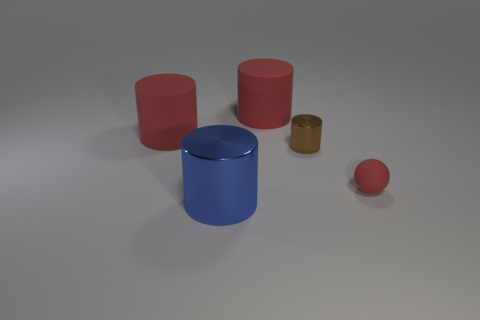Is the number of brown cylinders left of the large metallic thing greater than the number of objects?
Make the answer very short. No. The brown object that is made of the same material as the large blue object is what shape?
Ensure brevity in your answer.  Cylinder. There is a metallic cylinder behind the tiny red rubber sphere that is behind the large blue shiny cylinder; what is its color?
Your answer should be compact. Brown. Do the small red object and the small brown thing have the same shape?
Provide a short and direct response. No. What is the material of the tiny brown thing that is the same shape as the big metallic thing?
Give a very brief answer. Metal. Is there a small red object that is on the left side of the shiny cylinder that is on the left side of the shiny cylinder right of the large blue metal thing?
Keep it short and to the point. No. There is a blue metallic thing; does it have the same shape as the metallic object that is behind the big blue shiny thing?
Make the answer very short. Yes. Are there any other things that have the same color as the large metallic object?
Provide a succinct answer. No. There is a big cylinder in front of the brown shiny cylinder; is its color the same as the metallic cylinder right of the blue object?
Your answer should be very brief. No. Is there a small red matte cylinder?
Give a very brief answer. No. 